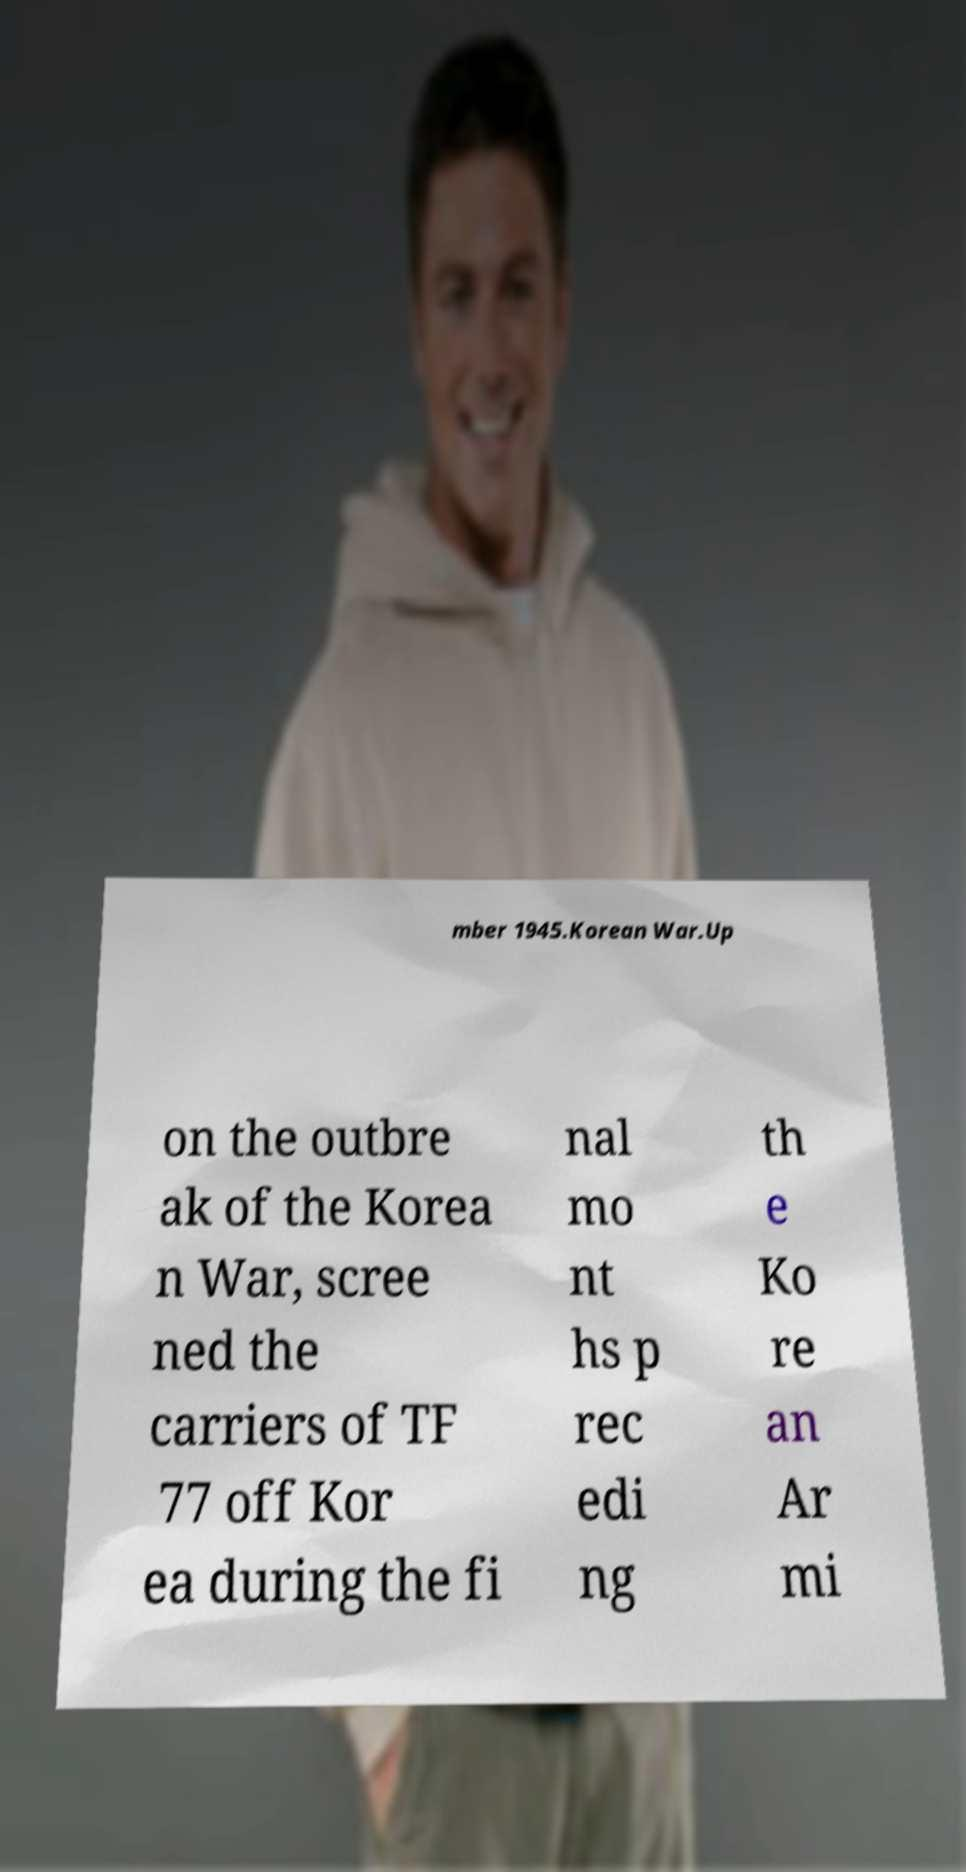Could you extract and type out the text from this image? mber 1945.Korean War.Up on the outbre ak of the Korea n War, scree ned the carriers of TF 77 off Kor ea during the fi nal mo nt hs p rec edi ng th e Ko re an Ar mi 